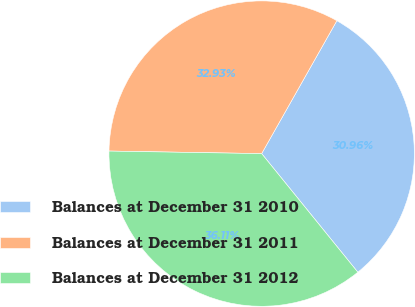<chart> <loc_0><loc_0><loc_500><loc_500><pie_chart><fcel>Balances at December 31 2010<fcel>Balances at December 31 2011<fcel>Balances at December 31 2012<nl><fcel>30.96%<fcel>32.93%<fcel>36.11%<nl></chart> 